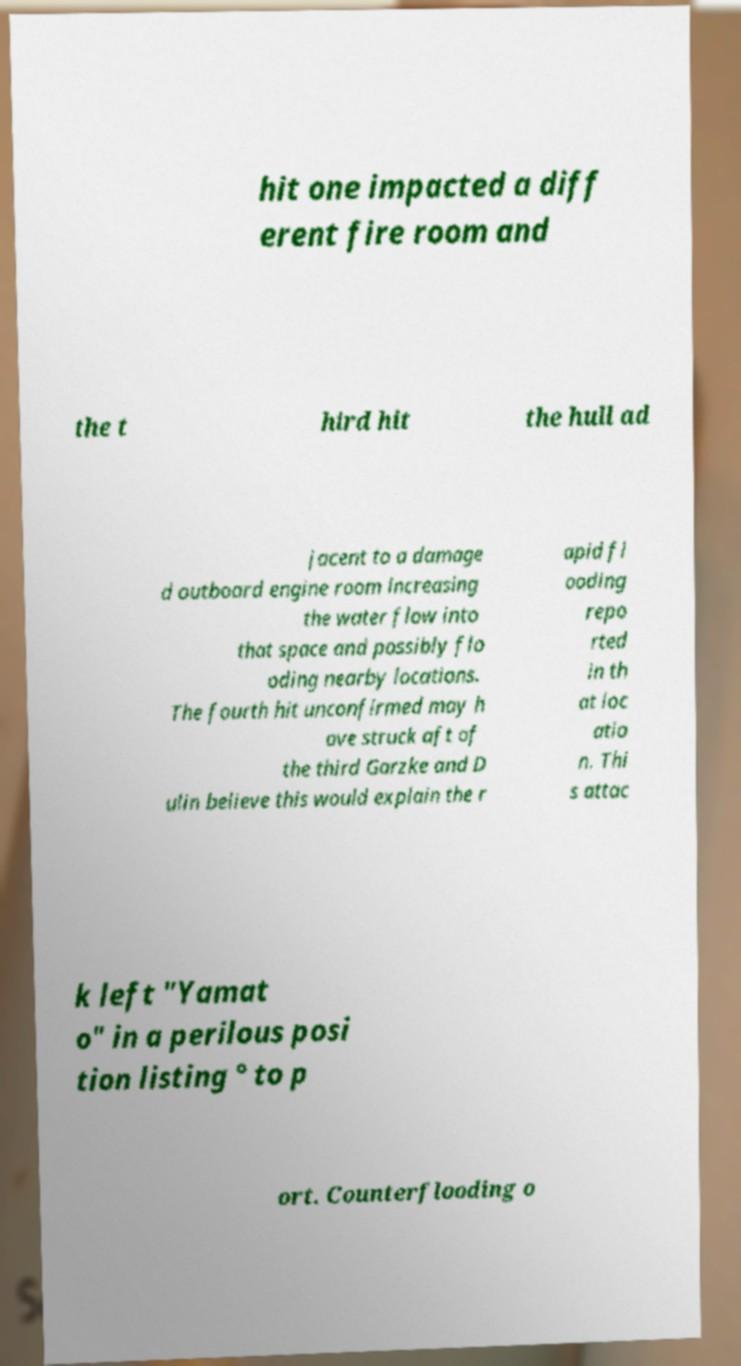What messages or text are displayed in this image? I need them in a readable, typed format. hit one impacted a diff erent fire room and the t hird hit the hull ad jacent to a damage d outboard engine room increasing the water flow into that space and possibly flo oding nearby locations. The fourth hit unconfirmed may h ave struck aft of the third Garzke and D ulin believe this would explain the r apid fl ooding repo rted in th at loc atio n. Thi s attac k left "Yamat o" in a perilous posi tion listing ° to p ort. Counterflooding o 